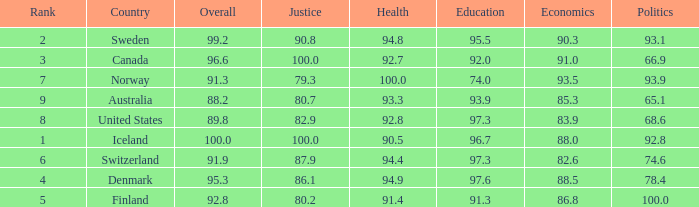Help me parse the entirety of this table. {'header': ['Rank', 'Country', 'Overall', 'Justice', 'Health', 'Education', 'Economics', 'Politics'], 'rows': [['2', 'Sweden', '99.2', '90.8', '94.8', '95.5', '90.3', '93.1'], ['3', 'Canada', '96.6', '100.0', '92.7', '92.0', '91.0', '66.9'], ['7', 'Norway', '91.3', '79.3', '100.0', '74.0', '93.5', '93.9'], ['9', 'Australia', '88.2', '80.7', '93.3', '93.9', '85.3', '65.1'], ['8', 'United States', '89.8', '82.9', '92.8', '97.3', '83.9', '68.6'], ['1', 'Iceland', '100.0', '100.0', '90.5', '96.7', '88.0', '92.8'], ['6', 'Switzerland', '91.9', '87.9', '94.4', '97.3', '82.6', '74.6'], ['4', 'Denmark', '95.3', '86.1', '94.9', '97.6', '88.5', '78.4'], ['5', 'Finland', '92.8', '80.2', '91.4', '91.3', '86.8', '100.0']]} What's the country with health being 91.4 Finland. 